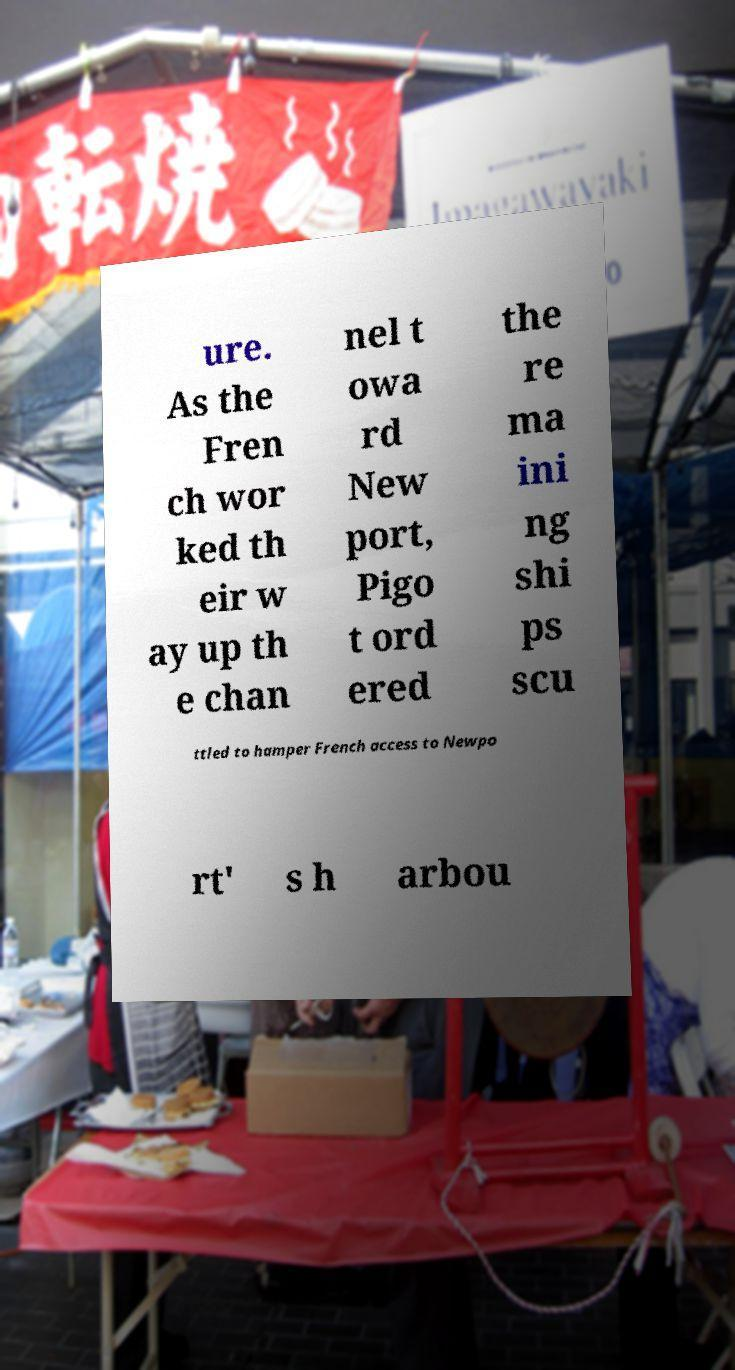Can you accurately transcribe the text from the provided image for me? ure. As the Fren ch wor ked th eir w ay up th e chan nel t owa rd New port, Pigo t ord ered the re ma ini ng shi ps scu ttled to hamper French access to Newpo rt' s h arbou 